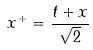Convert formula to latex. <formula><loc_0><loc_0><loc_500><loc_500>x ^ { + } = \frac { t + x } { \sqrt { 2 } }</formula> 